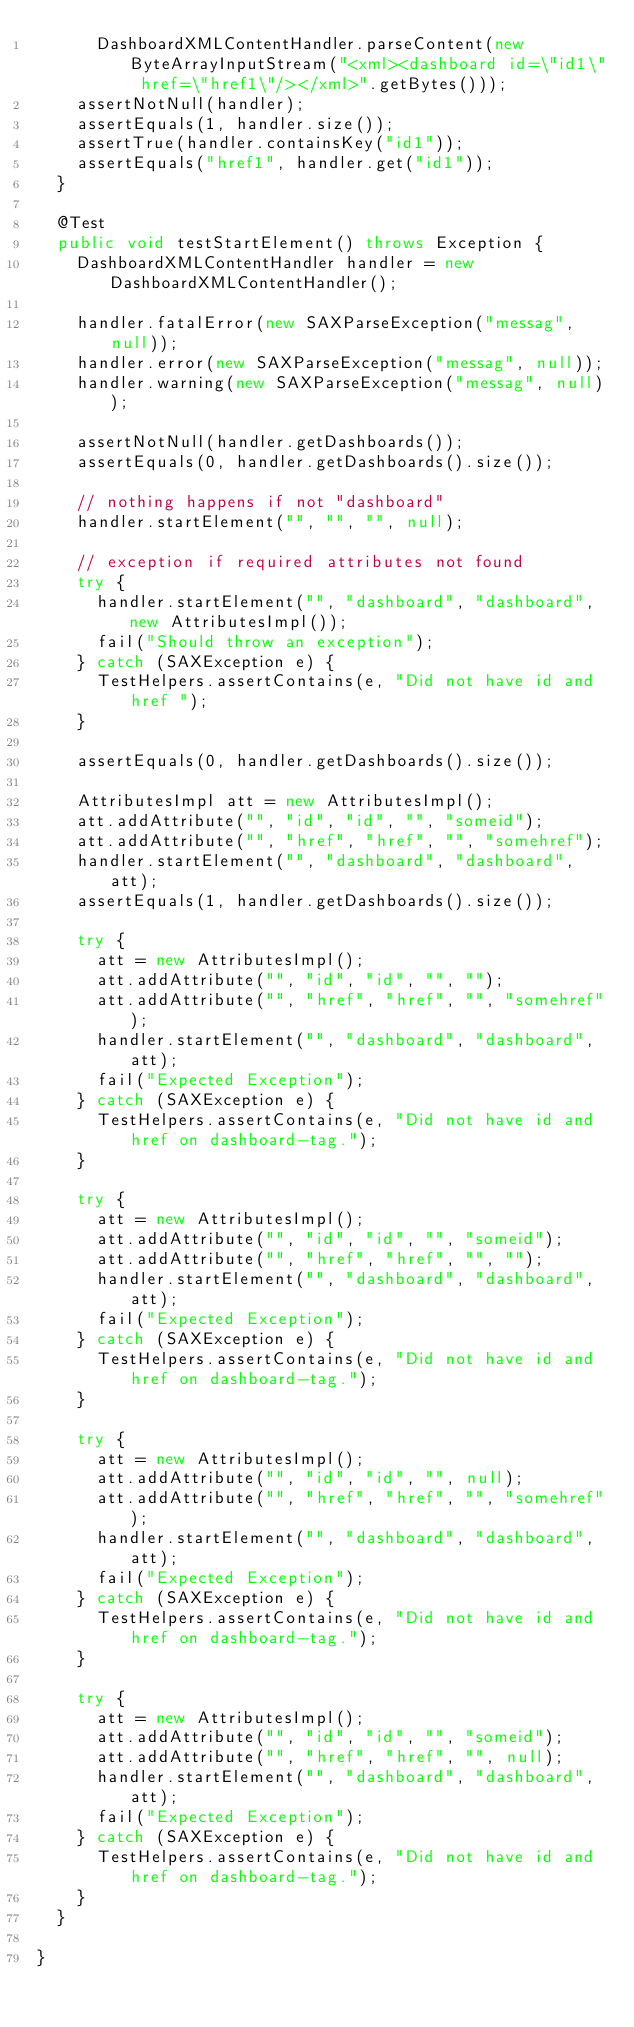Convert code to text. <code><loc_0><loc_0><loc_500><loc_500><_Java_>			DashboardXMLContentHandler.parseContent(new ByteArrayInputStream("<xml><dashboard id=\"id1\" href=\"href1\"/></xml>".getBytes()));
		assertNotNull(handler);
		assertEquals(1, handler.size());
		assertTrue(handler.containsKey("id1"));
		assertEquals("href1", handler.get("id1"));
	}

	@Test
	public void testStartElement() throws Exception {
		DashboardXMLContentHandler handler = new DashboardXMLContentHandler();

		handler.fatalError(new SAXParseException("messag", null));
		handler.error(new SAXParseException("messag", null));
		handler.warning(new SAXParseException("messag", null));

		assertNotNull(handler.getDashboards());
		assertEquals(0, handler.getDashboards().size());

		// nothing happens if not "dashboard"
		handler.startElement("", "", "", null);

		// exception if required attributes not found
		try {
			handler.startElement("", "dashboard", "dashboard", new AttributesImpl());
			fail("Should throw an exception");
		} catch (SAXException e) {
			TestHelpers.assertContains(e, "Did not have id and href ");
		}

		assertEquals(0, handler.getDashboards().size());

		AttributesImpl att = new AttributesImpl();
		att.addAttribute("", "id", "id", "", "someid");
		att.addAttribute("", "href", "href", "", "somehref");
		handler.startElement("", "dashboard", "dashboard", att);
		assertEquals(1, handler.getDashboards().size());

		try {
			att = new AttributesImpl();
			att.addAttribute("", "id", "id", "", "");
			att.addAttribute("", "href", "href", "", "somehref");
			handler.startElement("", "dashboard", "dashboard", att);
			fail("Expected Exception");
		} catch (SAXException e) {
			TestHelpers.assertContains(e, "Did not have id and href on dashboard-tag.");
		}

		try {
			att = new AttributesImpl();
			att.addAttribute("", "id", "id", "", "someid");
			att.addAttribute("", "href", "href", "", "");
			handler.startElement("", "dashboard", "dashboard", att);
			fail("Expected Exception");
		} catch (SAXException e) {
			TestHelpers.assertContains(e, "Did not have id and href on dashboard-tag.");
		}

		try {
			att = new AttributesImpl();
			att.addAttribute("", "id", "id", "", null);
			att.addAttribute("", "href", "href", "", "somehref");
			handler.startElement("", "dashboard", "dashboard", att);
			fail("Expected Exception");
		} catch (SAXException e) {
			TestHelpers.assertContains(e, "Did not have id and href on dashboard-tag.");
		}

		try {
			att = new AttributesImpl();
			att.addAttribute("", "id", "id", "", "someid");
			att.addAttribute("", "href", "href", "", null);
			handler.startElement("", "dashboard", "dashboard", att);
			fail("Expected Exception");
		} catch (SAXException e) {
			TestHelpers.assertContains(e, "Did not have id and href on dashboard-tag.");
		}
	}

}
</code> 